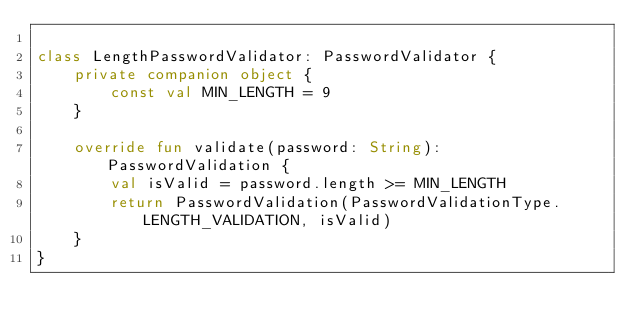<code> <loc_0><loc_0><loc_500><loc_500><_Kotlin_>
class LengthPasswordValidator: PasswordValidator {
    private companion object {
        const val MIN_LENGTH = 9
    }

    override fun validate(password: String): PasswordValidation {
        val isValid = password.length >= MIN_LENGTH
        return PasswordValidation(PasswordValidationType.LENGTH_VALIDATION, isValid)
    }
}</code> 